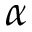Convert formula to latex. <formula><loc_0><loc_0><loc_500><loc_500>\alpha</formula> 